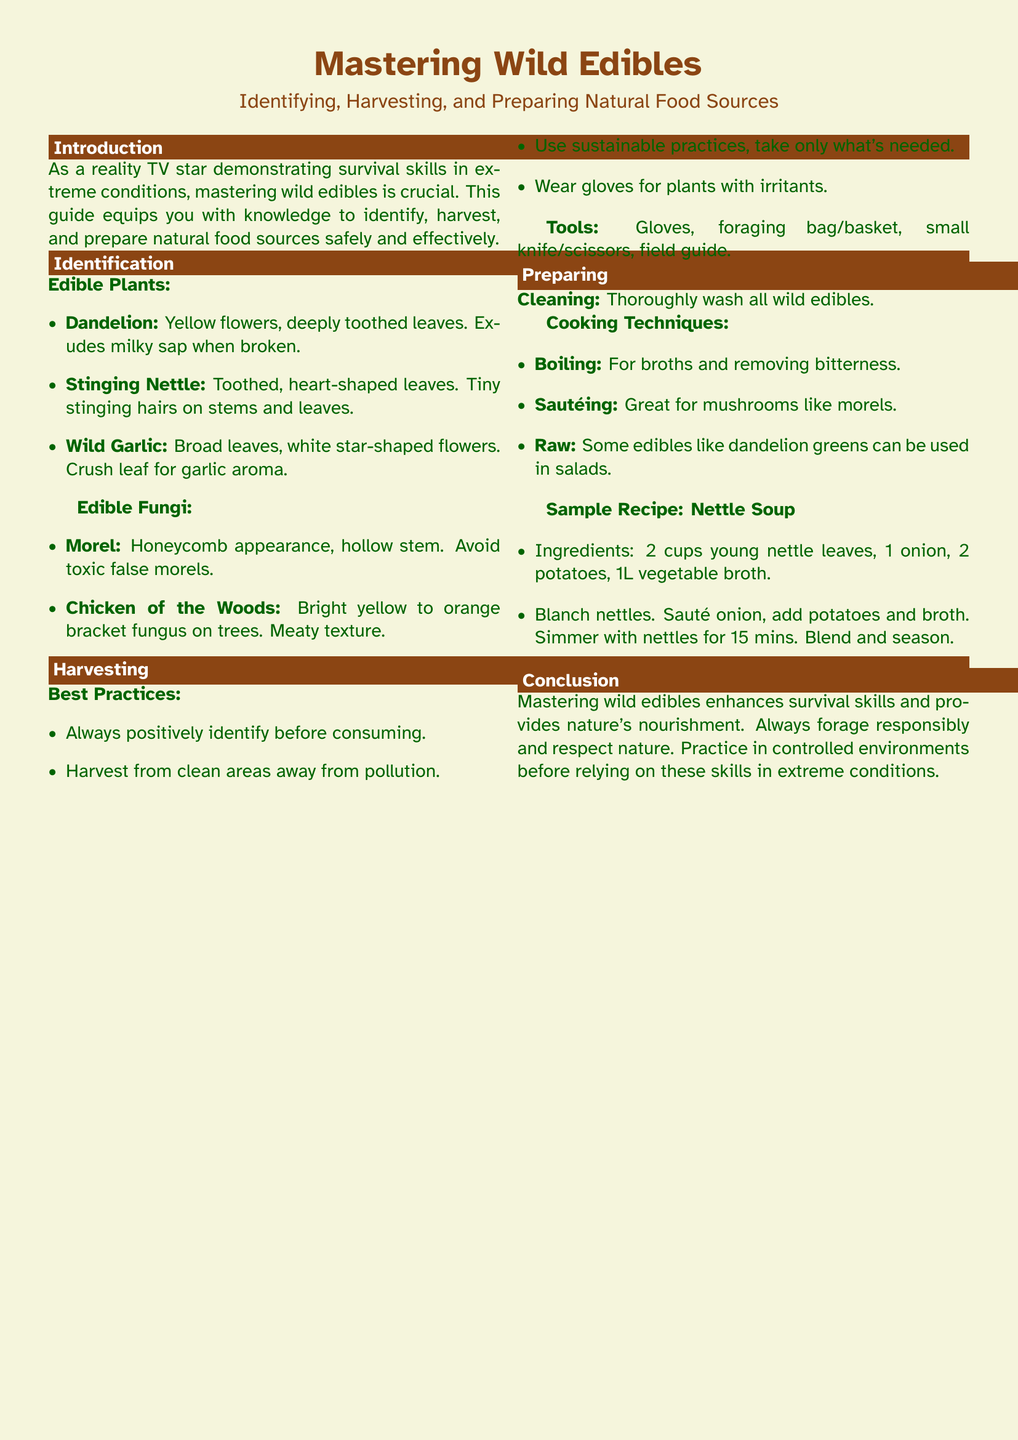What is the title of the guide? The title of the guide is prominently mentioned at the top of the document.
Answer: Mastering Wild Edibles How many types of edible plants are mentioned? The section details the edible plants listed in the document.
Answer: 3 Name one edible fungi listed in the guide. The guide provides a list of edible fungi.
Answer: Morel What is the recommended practice for harvesting wild edibles? The document specifies best practices for responsible harvesting.
Answer: Sustainable practices What is the first step in preparing wild edibles? The preparation section starts with the importance of cleanliness.
Answer: Cleaning What cooking method is suggested for removing bitterness? The guide outlines cooking techniques including one for bitterness removal.
Answer: Boiling What ingredient is included in the sample recipe for Nettle Soup? The recipe details the ingredients used for Nettle Soup.
Answer: Young nettle leaves How long should you simmer the nettles in the soup? The cooking instructions in the recipe specify a simmering time.
Answer: 15 minutes What color are the flowers of the wild garlic? The appearance of the wild garlic is described in the identification section.
Answer: White 